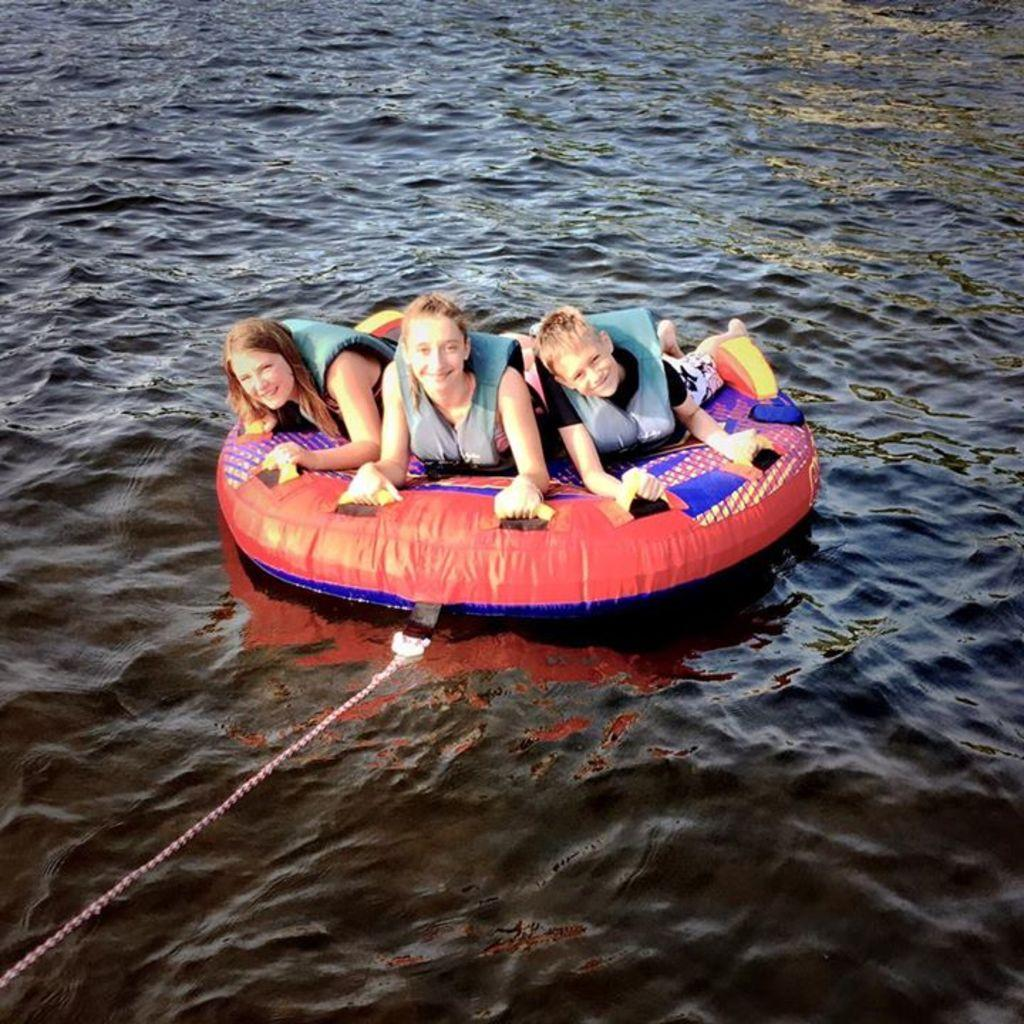How many children are in the image? There are three children in the image. What are the children wearing? The children are wearing gray jackets. What is the facial expression of the children? The children are smiling. What are the children lying on in the image? The children are lying on a tube boat. What is the condition of the tube boat? The tube boat has a thread. Where is the tube boat located? The tube boat is on the water. Can you tell me how many toes the children have in the image? The image does not show the children's toes, so it is not possible to determine the number of toes they have. 